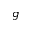Convert formula to latex. <formula><loc_0><loc_0><loc_500><loc_500>g</formula> 